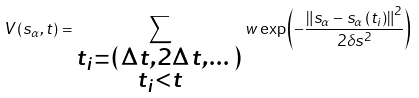<formula> <loc_0><loc_0><loc_500><loc_500>V \left ( s _ { \alpha } , t \right ) = \sum _ { \substack { t _ { i } = \left ( \Delta t , 2 \Delta t , \dots \right ) \\ t _ { i } < t } } w \exp \left ( - \frac { \left \| s _ { \alpha } - s _ { \alpha } \left ( t _ { i } \right ) \right \| ^ { 2 } } { 2 \delta s ^ { 2 } } \right )</formula> 